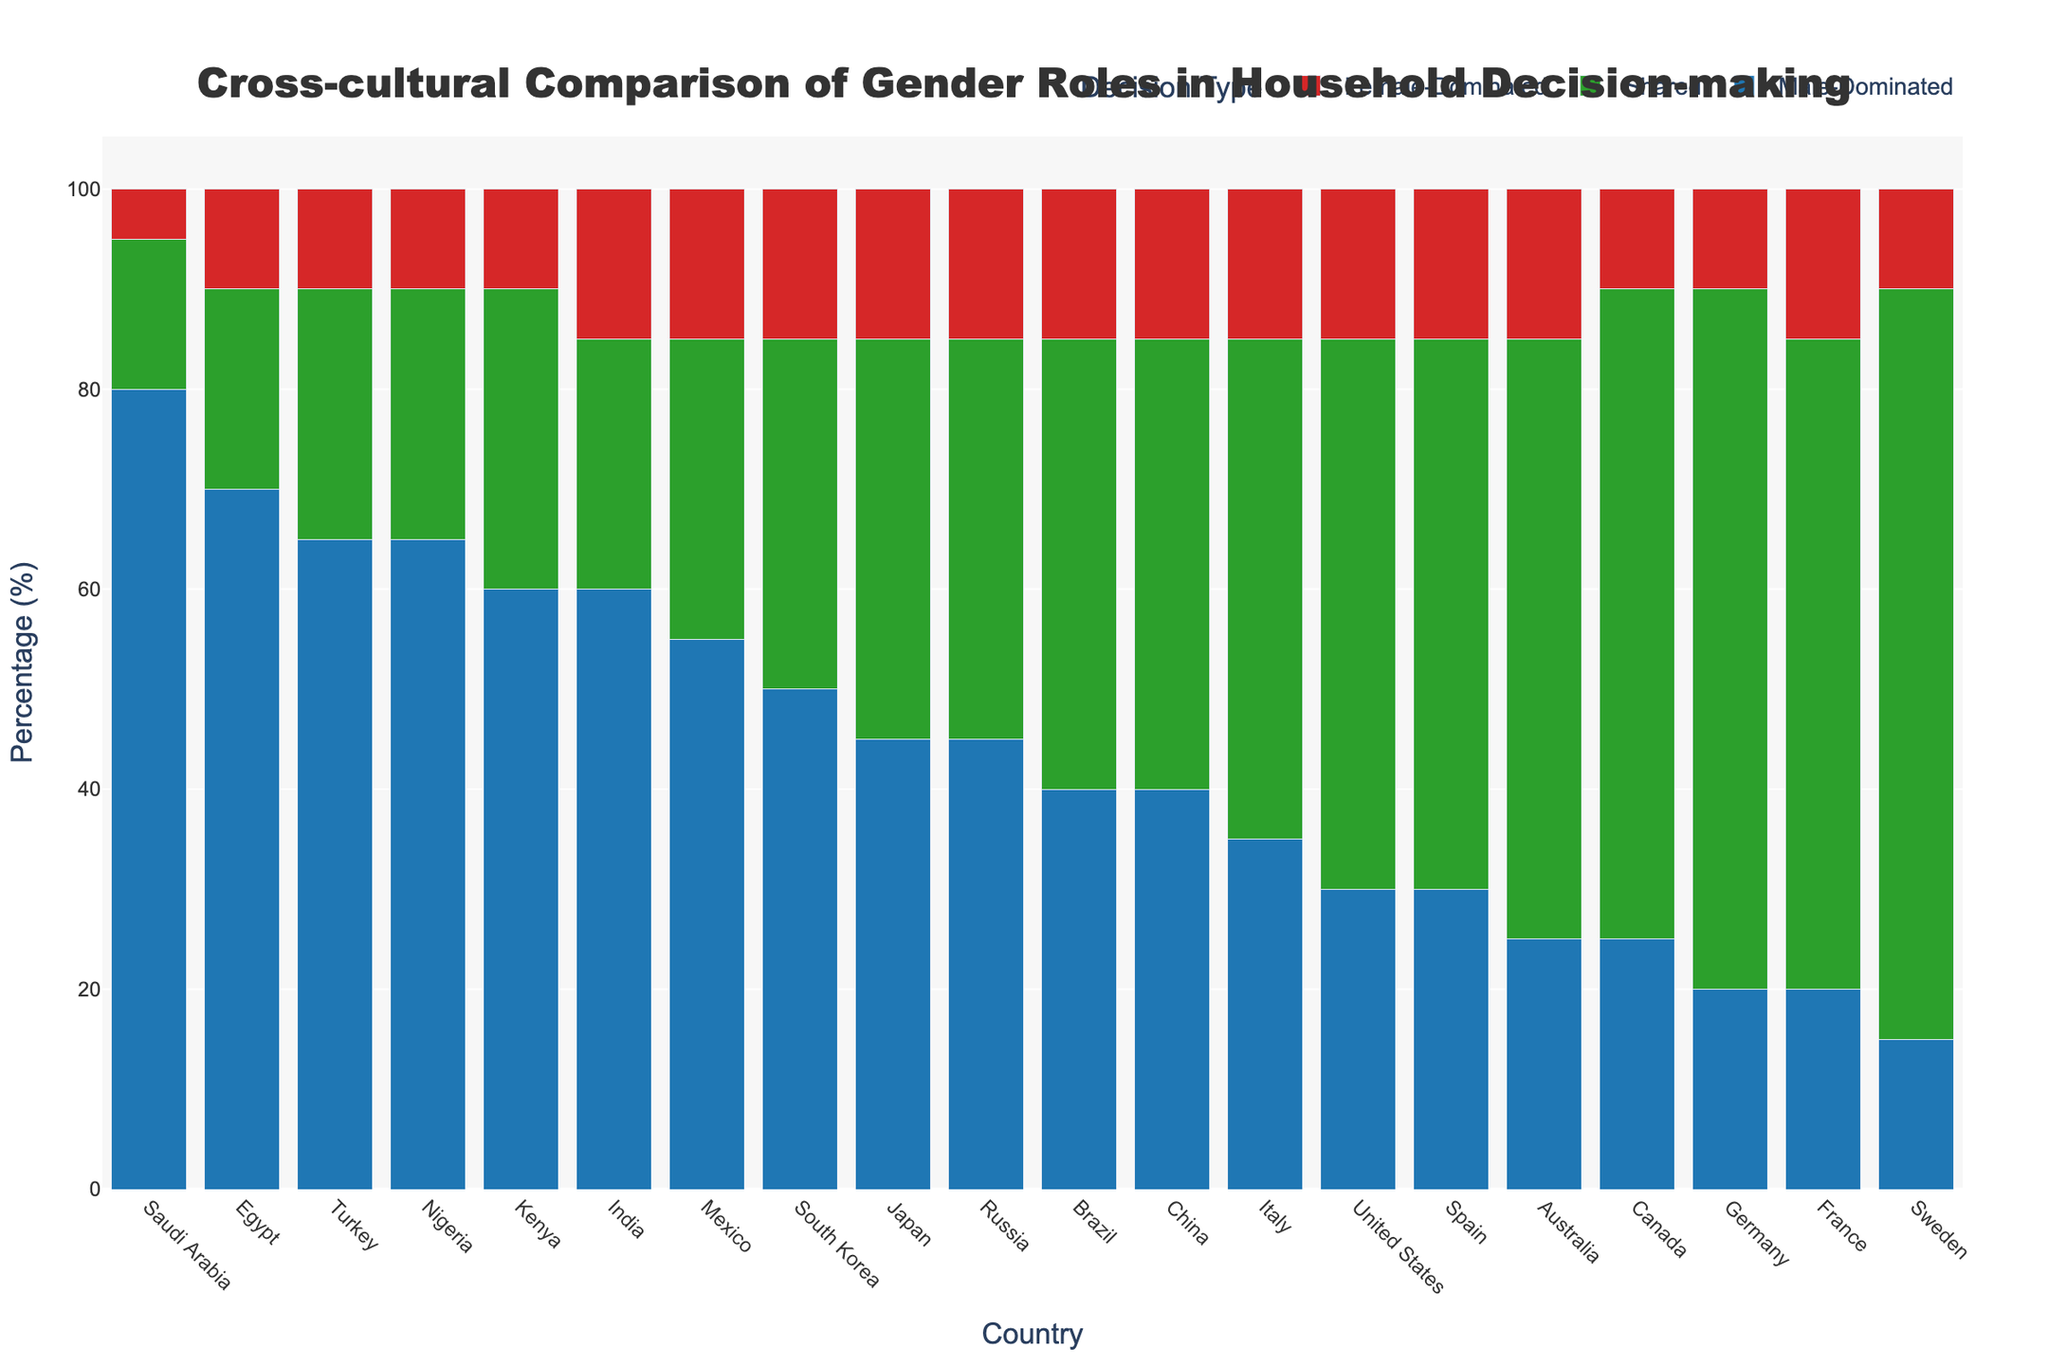Which country has the highest percentage of male-dominated decisions? By examining the heights of the blue bars representing male-dominated decisions, we can see that Saudi Arabia has the highest bar, indicating the largest percentage of male-dominated decisions.
Answer: Saudi Arabia How many countries have more than 50% of household decisions dominated by males? By counting the blue bars exceeding the 50% mark on the Y-axis, we identify seven countries: Japan, India, Egypt, Nigeria, South Korea, Mexico, and Saudi Arabia.
Answer: 7 Which countries have the highest and lowest percentages of shared decisions? The green bars for shared decisions show the highest percentage for Sweden and Germany (both 75%), and the lowest percentage for Saudi Arabia (15%).
Answer: Sweden and Germany for highest, Saudi Arabia for lowest What is the percentage difference in male-dominated decisions between Saudi Arabia and Canada? By examining the blue bars, Saudi Arabia has 80% and Canada has 25% for male-dominated decisions. The difference is 80% - 25% = 55%.
Answer: 55% Which country has the largest discrepancy between male-dominated and female-dominated decision percentages? By analyzing the difference between blue bars and red bars, Saudi Arabia shows the largest discrepancy with an 80% male-dominated and 5% female-dominated, a difference of 75%.
Answer: Saudi Arabia Which country has the closest proportion of male-dominated, shared, and female-dominated decisions? The country where the blue, green, and red bars are most even is Japan, with 45% male, 40% shared, and 15% female.
Answer: Japan What is the combined percentage of shared and female-dominated decisions for Egypt? For Egypt, shared decisions are 20% and female-dominated decisions are 10%. The combined percentage is 20% + 10% = 30%.
Answer: 30% Compare the percentage of shared decisions between the United States and Australia. Which country has a higher value and by how much? For shared decisions, the United States has 55% and Australia has 60%. Australia has a higher value by 60% - 55% = 5%.
Answer: Australia by 5% What is the average percentage of male-dominated decisions across all countries? Summing up the percentages of male-dominated decisions across all countries (15+45+30+60+40+70+65+25+20+50+55+80+25+45+20+60+35+40+30+65) gives 875. Dividing by the number of countries (20) gives an average of 875 / 20 = 43.75%.
Answer: 43.75% Identify the countries where female-dominated decisions account for exactly 15%. By looking at the red bars, countries with 15% female-dominated decisions are Japan, United States, India, Brazil, Australia, South Korea, Mexico, Russia, France, and Italy.
Answer: Japan, United States, India, Brazil, Australia, South Korea, Mexico, Russia, France, Italy 